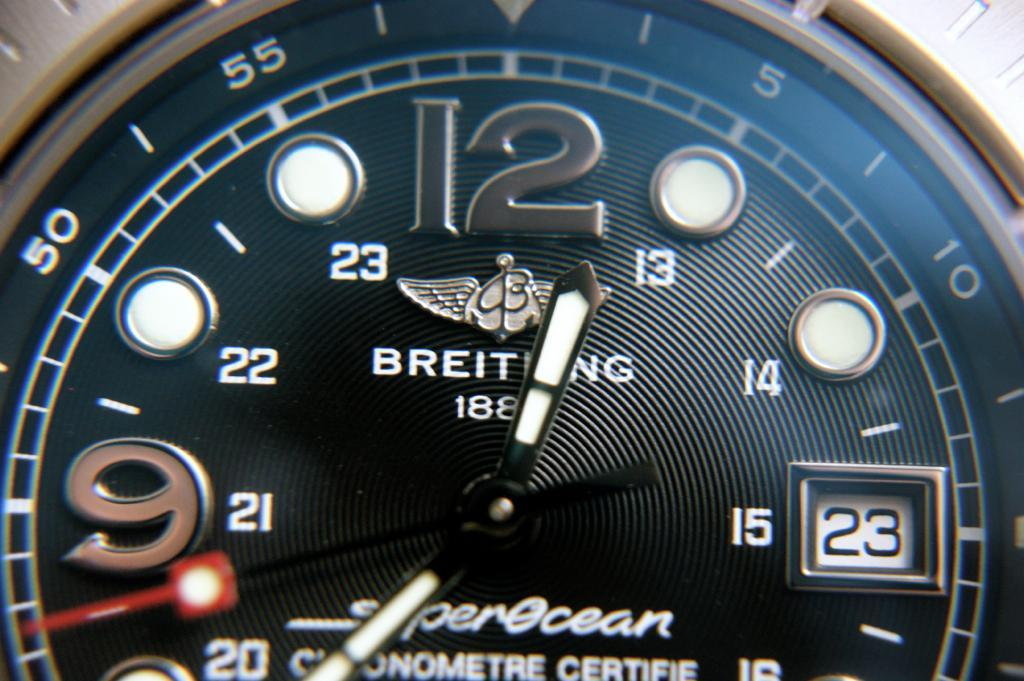Provide a one-sentence caption for the provided image. A Breitling watch ays that today is the 23rd of the month. 